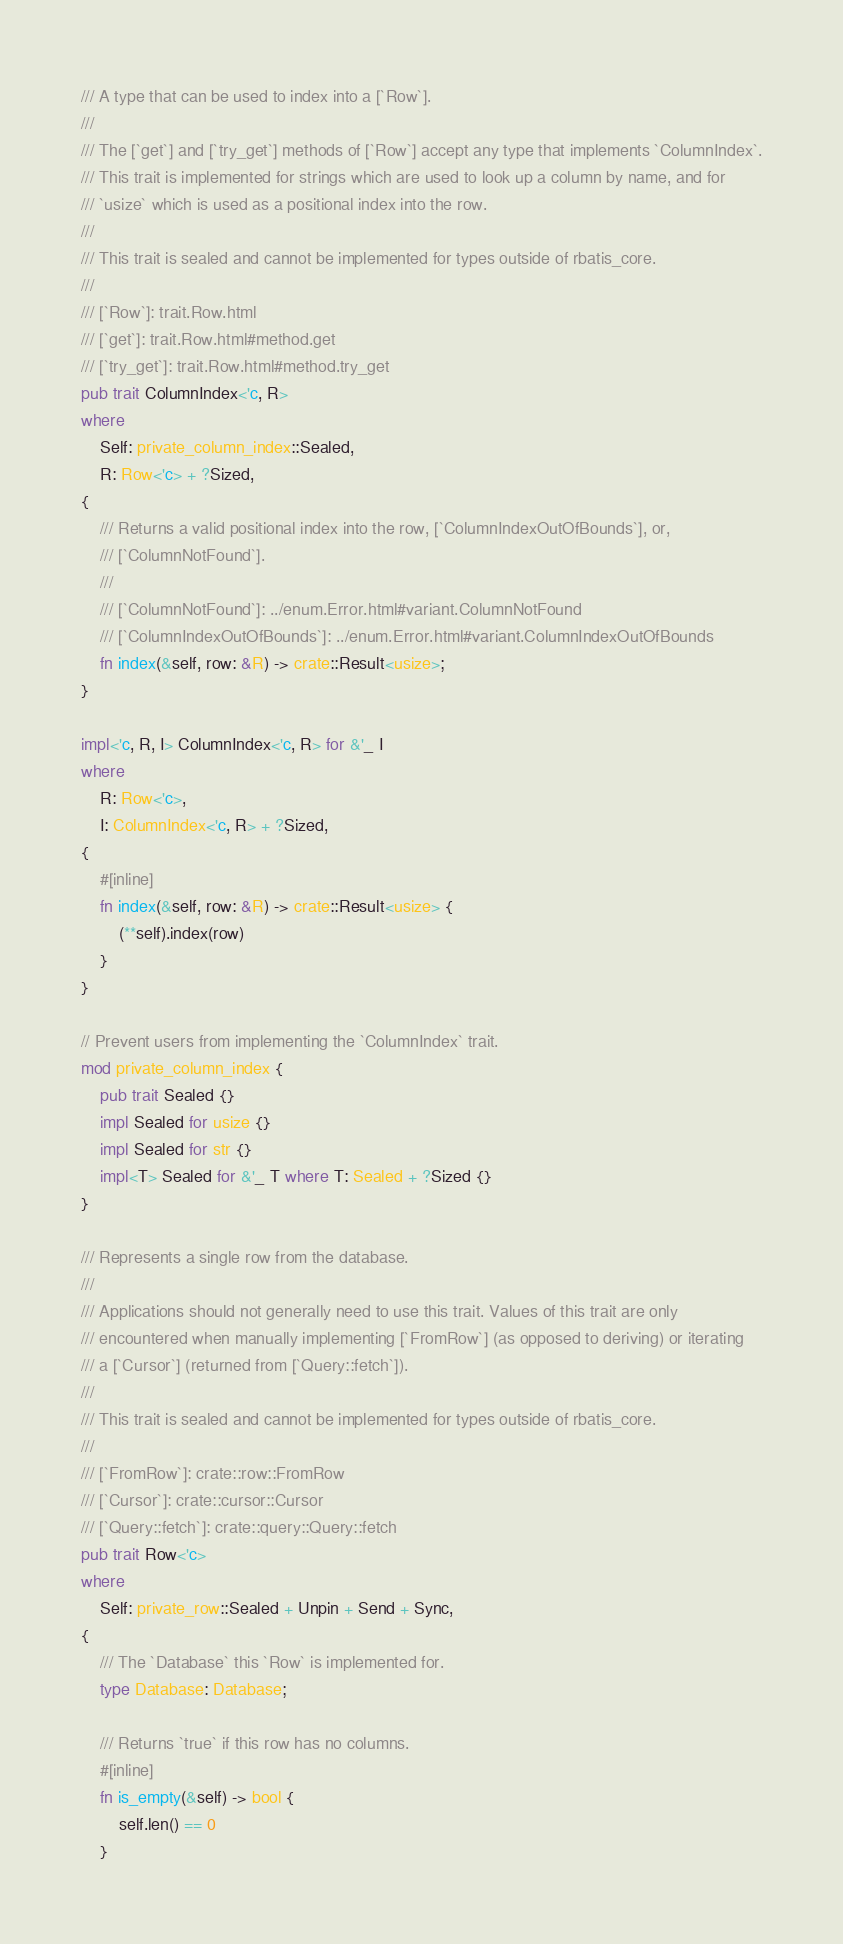<code> <loc_0><loc_0><loc_500><loc_500><_Rust_>/// A type that can be used to index into a [`Row`].
///
/// The [`get`] and [`try_get`] methods of [`Row`] accept any type that implements `ColumnIndex`.
/// This trait is implemented for strings which are used to look up a column by name, and for
/// `usize` which is used as a positional index into the row.
///
/// This trait is sealed and cannot be implemented for types outside of rbatis_core.
///
/// [`Row`]: trait.Row.html
/// [`get`]: trait.Row.html#method.get
/// [`try_get`]: trait.Row.html#method.try_get
pub trait ColumnIndex<'c, R>
where
    Self: private_column_index::Sealed,
    R: Row<'c> + ?Sized,
{
    /// Returns a valid positional index into the row, [`ColumnIndexOutOfBounds`], or,
    /// [`ColumnNotFound`].
    ///
    /// [`ColumnNotFound`]: ../enum.Error.html#variant.ColumnNotFound
    /// [`ColumnIndexOutOfBounds`]: ../enum.Error.html#variant.ColumnIndexOutOfBounds
    fn index(&self, row: &R) -> crate::Result<usize>;
}

impl<'c, R, I> ColumnIndex<'c, R> for &'_ I
where
    R: Row<'c>,
    I: ColumnIndex<'c, R> + ?Sized,
{
    #[inline]
    fn index(&self, row: &R) -> crate::Result<usize> {
        (**self).index(row)
    }
}

// Prevent users from implementing the `ColumnIndex` trait.
mod private_column_index {
    pub trait Sealed {}
    impl Sealed for usize {}
    impl Sealed for str {}
    impl<T> Sealed for &'_ T where T: Sealed + ?Sized {}
}

/// Represents a single row from the database.
///
/// Applications should not generally need to use this trait. Values of this trait are only
/// encountered when manually implementing [`FromRow`] (as opposed to deriving) or iterating
/// a [`Cursor`] (returned from [`Query::fetch`]).
///
/// This trait is sealed and cannot be implemented for types outside of rbatis_core.
///
/// [`FromRow`]: crate::row::FromRow
/// [`Cursor`]: crate::cursor::Cursor
/// [`Query::fetch`]: crate::query::Query::fetch
pub trait Row<'c>
where
    Self: private_row::Sealed + Unpin + Send + Sync,
{
    /// The `Database` this `Row` is implemented for.
    type Database: Database;

    /// Returns `true` if this row has no columns.
    #[inline]
    fn is_empty(&self) -> bool {
        self.len() == 0
    }
</code> 